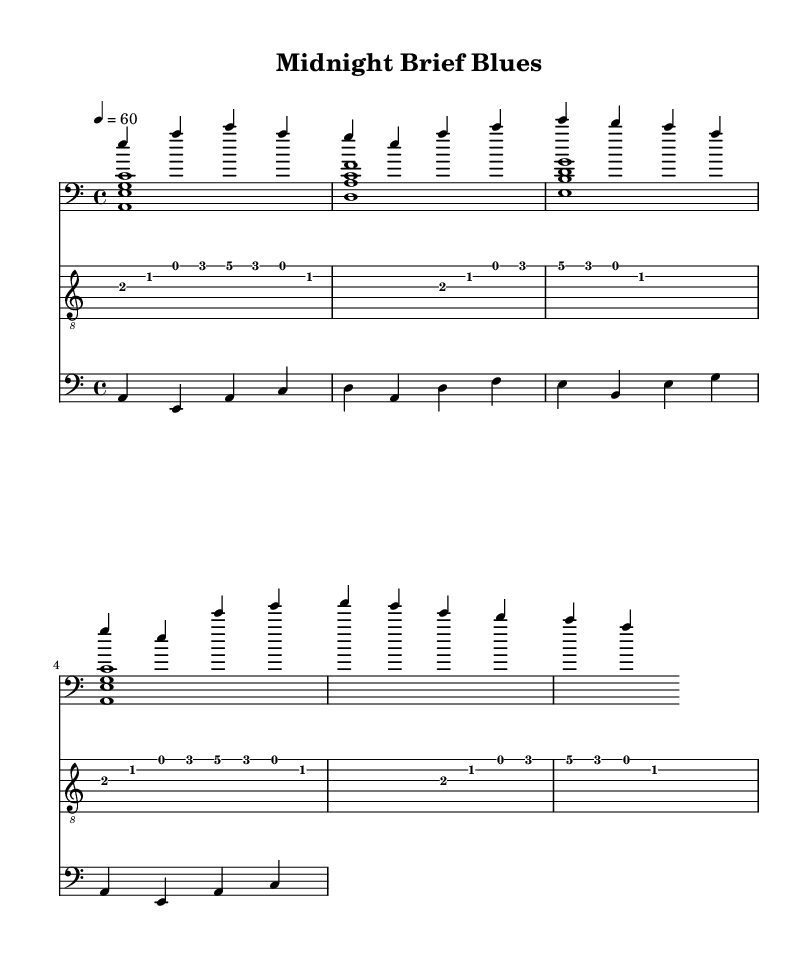What is the key signature of this music? The key signature shows one flat (B♭), which indicates the music is in A minor, the relative minor of C major.
Answer: A minor What is the time signature of this music? The time signature is indicated at the beginning as 4/4, meaning there are four beats in a measure and the quarter note gets one beat.
Answer: 4/4 What is the tempo marking of this music? The tempo marking is shown as "4 = 60", which indicates that the quarter note is to be played at 60 beats per minute.
Answer: 60 BPM How many measures are in the verse section of the music? The verse section consists of four measures, as shown by the notation and spacing in the provided lines.
Answer: 4 measures What is the structure of the piece in terms of sections? The music is structured into at least an intro, verse, and chorus, as indicated by the corresponding labeled parts within the sheet.
Answer: Intro, Verse, Chorus What is the relationship between the left-hand piano part and the bass? The left-hand piano part reinforces the harmonic structure played in the bass by using similar chord shapes, emphasizing the root notes of the bass lines.
Answer: Harmonically complementary What rhythmic feel is demonstrated by the guitar part in the music? The guitar part utilizes eighth notes and rests that create a slow, laid-back feel typical of the blues genre, enhancing the reflective nature of the piece.
Answer: Laid-back blues feel 